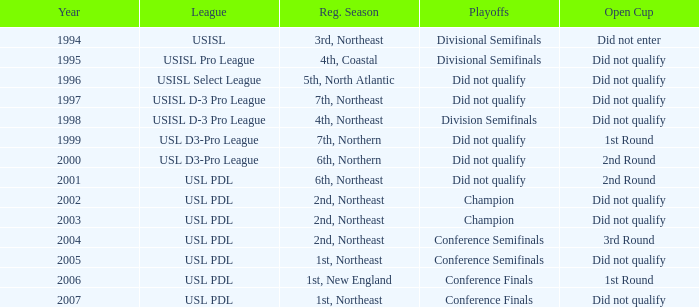Indicate the complete sum of years for usisl pro league. 1.0. 